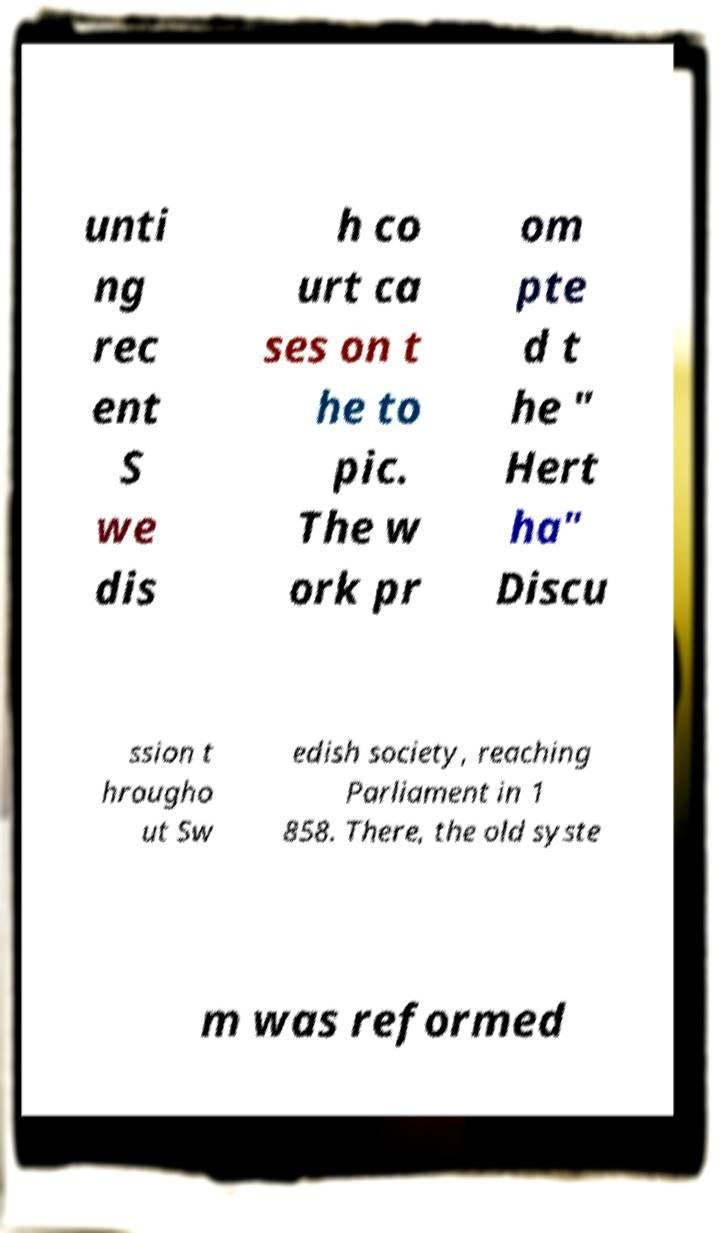Can you read and provide the text displayed in the image?This photo seems to have some interesting text. Can you extract and type it out for me? unti ng rec ent S we dis h co urt ca ses on t he to pic. The w ork pr om pte d t he " Hert ha" Discu ssion t hrougho ut Sw edish society, reaching Parliament in 1 858. There, the old syste m was reformed 